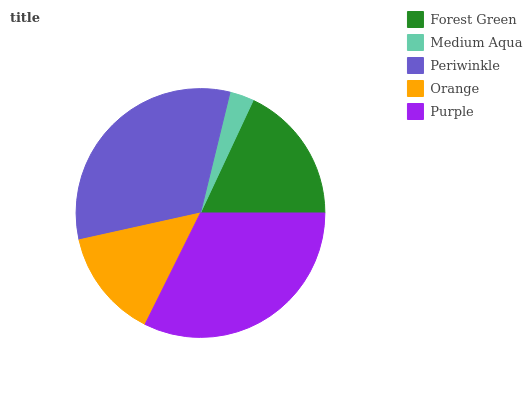Is Medium Aqua the minimum?
Answer yes or no. Yes. Is Purple the maximum?
Answer yes or no. Yes. Is Periwinkle the minimum?
Answer yes or no. No. Is Periwinkle the maximum?
Answer yes or no. No. Is Periwinkle greater than Medium Aqua?
Answer yes or no. Yes. Is Medium Aqua less than Periwinkle?
Answer yes or no. Yes. Is Medium Aqua greater than Periwinkle?
Answer yes or no. No. Is Periwinkle less than Medium Aqua?
Answer yes or no. No. Is Forest Green the high median?
Answer yes or no. Yes. Is Forest Green the low median?
Answer yes or no. Yes. Is Purple the high median?
Answer yes or no. No. Is Medium Aqua the low median?
Answer yes or no. No. 